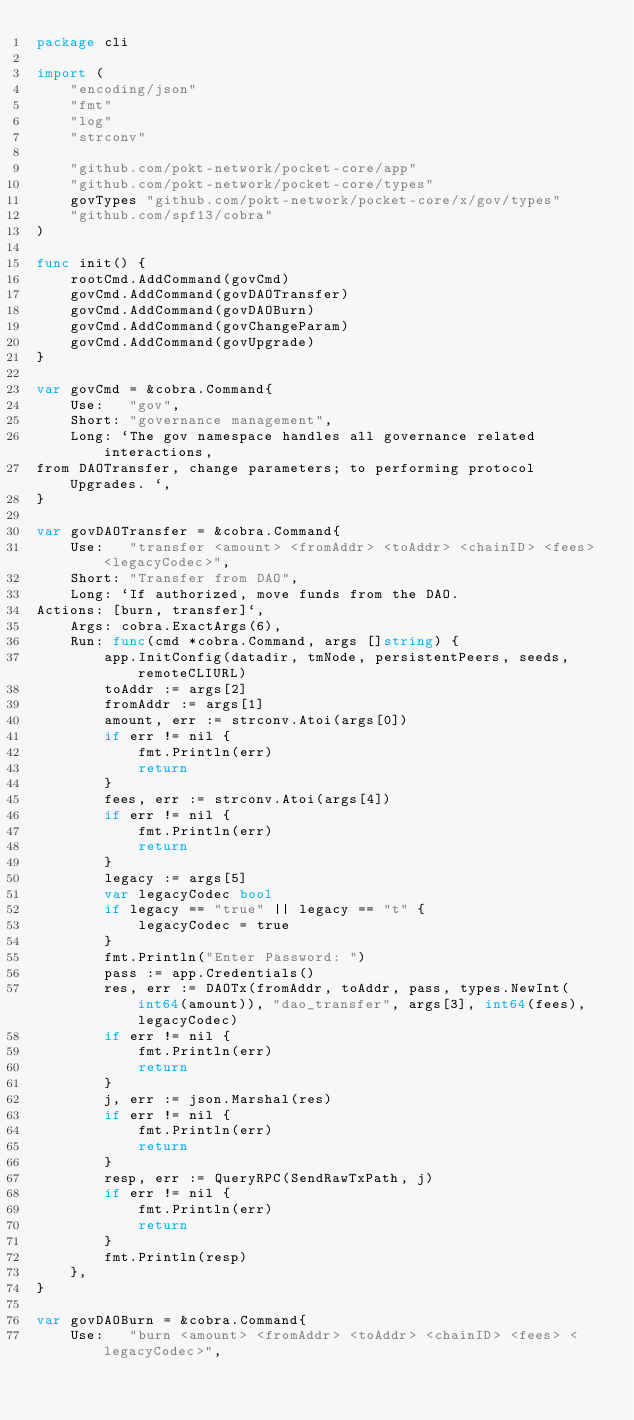Convert code to text. <code><loc_0><loc_0><loc_500><loc_500><_Go_>package cli

import (
	"encoding/json"
	"fmt"
	"log"
	"strconv"

	"github.com/pokt-network/pocket-core/app"
	"github.com/pokt-network/pocket-core/types"
	govTypes "github.com/pokt-network/pocket-core/x/gov/types"
	"github.com/spf13/cobra"
)

func init() {
	rootCmd.AddCommand(govCmd)
	govCmd.AddCommand(govDAOTransfer)
	govCmd.AddCommand(govDAOBurn)
	govCmd.AddCommand(govChangeParam)
	govCmd.AddCommand(govUpgrade)
}

var govCmd = &cobra.Command{
	Use:   "gov",
	Short: "governance management",
	Long: `The gov namespace handles all governance related interactions,
from DAOTransfer, change parameters; to performing protocol Upgrades. `,
}

var govDAOTransfer = &cobra.Command{
	Use:   "transfer <amount> <fromAddr> <toAddr> <chainID> <fees> <legacyCodec>",
	Short: "Transfer from DAO",
	Long: `If authorized, move funds from the DAO.
Actions: [burn, transfer]`,
	Args: cobra.ExactArgs(6),
	Run: func(cmd *cobra.Command, args []string) {
		app.InitConfig(datadir, tmNode, persistentPeers, seeds, remoteCLIURL)
		toAddr := args[2]
		fromAddr := args[1]
		amount, err := strconv.Atoi(args[0])
		if err != nil {
			fmt.Println(err)
			return
		}
		fees, err := strconv.Atoi(args[4])
		if err != nil {
			fmt.Println(err)
			return
		}
		legacy := args[5]
		var legacyCodec bool
		if legacy == "true" || legacy == "t" {
			legacyCodec = true
		}
		fmt.Println("Enter Password: ")
		pass := app.Credentials()
		res, err := DAOTx(fromAddr, toAddr, pass, types.NewInt(int64(amount)), "dao_transfer", args[3], int64(fees), legacyCodec)
		if err != nil {
			fmt.Println(err)
			return
		}
		j, err := json.Marshal(res)
		if err != nil {
			fmt.Println(err)
			return
		}
		resp, err := QueryRPC(SendRawTxPath, j)
		if err != nil {
			fmt.Println(err)
			return
		}
		fmt.Println(resp)
	},
}

var govDAOBurn = &cobra.Command{
	Use:   "burn <amount> <fromAddr> <toAddr> <chainID> <fees> <legacyCodec>",</code> 